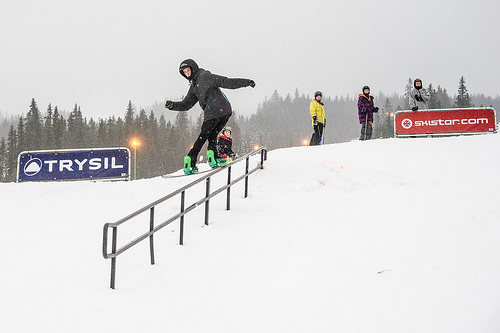How would you describe the weather conditions in this image? The weather appears to be typical of a snowy winter day with overcast skies and perhaps some gentle snowfall, ideal for skiing and snowboarding. If you were in this scene, what would be the first thing you would do? If I were in this scene, the first thing I would do is grab my snowboard and head for the hill to join in the fun, eager to carve through the fresh snow alongside the others enjoying the slope. Imagine an epic snowboarding race starting from the top of the hill. Describe the build-up to the race and the first moments after the start signal. As the crowd gathers at the base of the hill, there's an electrifying buzz in the air. Competitors, clad in vibrant, aerodynamic suits, make their way to the top, their snowboards gleaming under the overcast sky. Spectators cheer and hold up colorful banners, the atmosphere charged with anticipation. Suddenly, a loud horn signals the start of the race, and the snowboarders launch themselves down the hill with incredible speed. Snow sprays into the air as they carve sharp turns and perform daring tricks to gain an edge over their rivals. The race is on, and the thrill is palpable as everyone watches the competitors navigate the challenging terrain. 